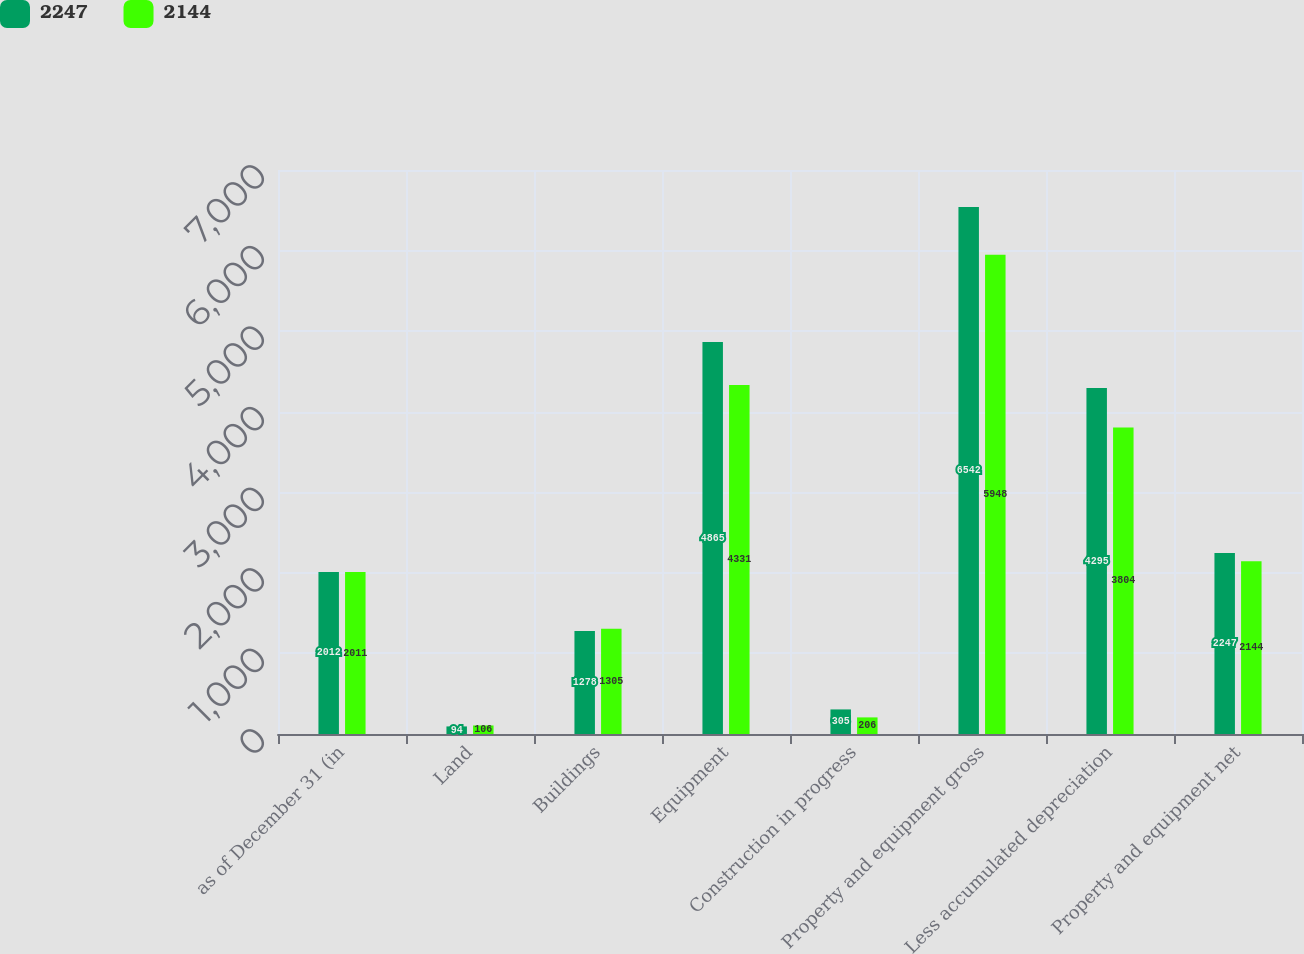Convert chart to OTSL. <chart><loc_0><loc_0><loc_500><loc_500><stacked_bar_chart><ecel><fcel>as of December 31 (in<fcel>Land<fcel>Buildings<fcel>Equipment<fcel>Construction in progress<fcel>Property and equipment gross<fcel>Less accumulated depreciation<fcel>Property and equipment net<nl><fcel>2247<fcel>2012<fcel>94<fcel>1278<fcel>4865<fcel>305<fcel>6542<fcel>4295<fcel>2247<nl><fcel>2144<fcel>2011<fcel>106<fcel>1305<fcel>4331<fcel>206<fcel>5948<fcel>3804<fcel>2144<nl></chart> 